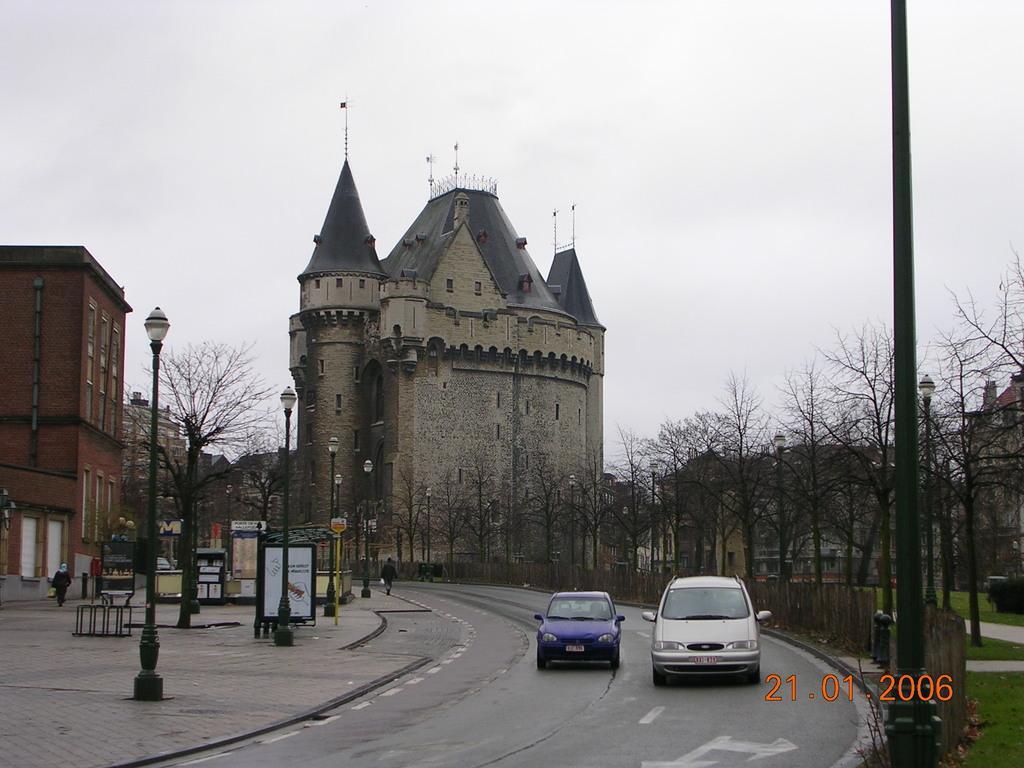In one or two sentences, can you explain what this image depicts? In this image I can see few buildings, windows, dry trees, boards, sign boards, poles, light poles, few people, sky and few vehicles on the road. 